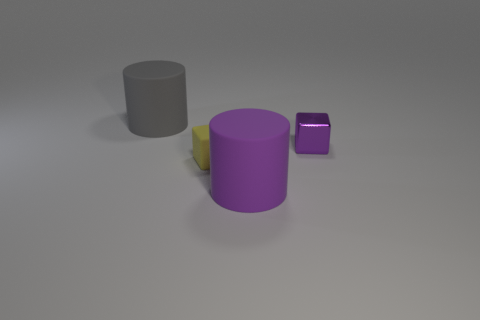Is there anything else that has the same material as the small purple thing?
Provide a short and direct response. No. There is a small metallic object; does it have the same color as the tiny cube left of the big purple cylinder?
Your response must be concise. No. How many cylinders are either small metal things or large purple objects?
Provide a succinct answer. 1. There is a large cylinder that is behind the purple shiny cube; what is its color?
Your answer should be very brief. Gray. The object that is the same color as the small metallic block is what shape?
Offer a very short reply. Cylinder. How many metallic blocks have the same size as the gray rubber object?
Provide a short and direct response. 0. There is a gray thing behind the small yellow block; is it the same shape as the tiny thing right of the small rubber block?
Your answer should be very brief. No. There is a cylinder in front of the thing right of the cylinder that is in front of the small purple cube; what is it made of?
Provide a succinct answer. Rubber. There is a thing that is the same size as the purple cube; what shape is it?
Offer a very short reply. Cube. Is there a matte block of the same color as the tiny metallic cube?
Ensure brevity in your answer.  No. 